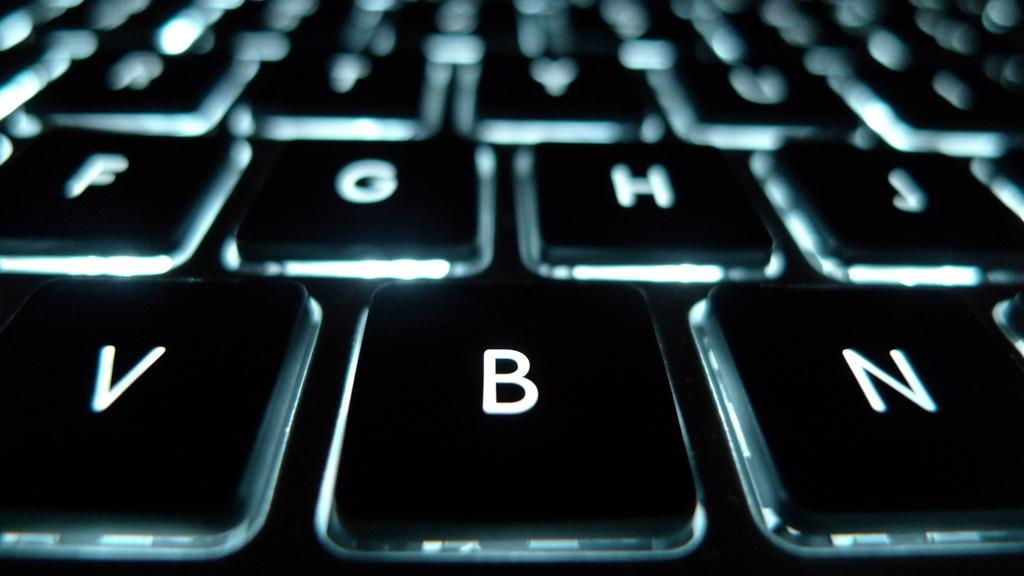Provide a one-sentence caption for the provided image. Keyboard with alphabet letters like V, B, N, H, and J. 